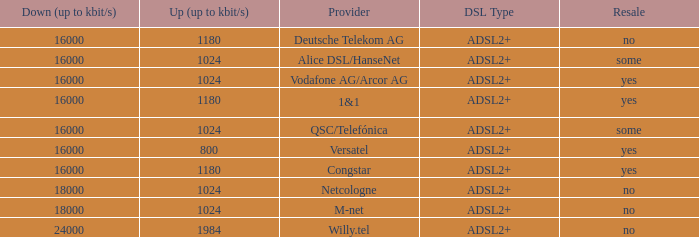Can you list all the dsl types that m-net telecom company offers? ADSL2+. 